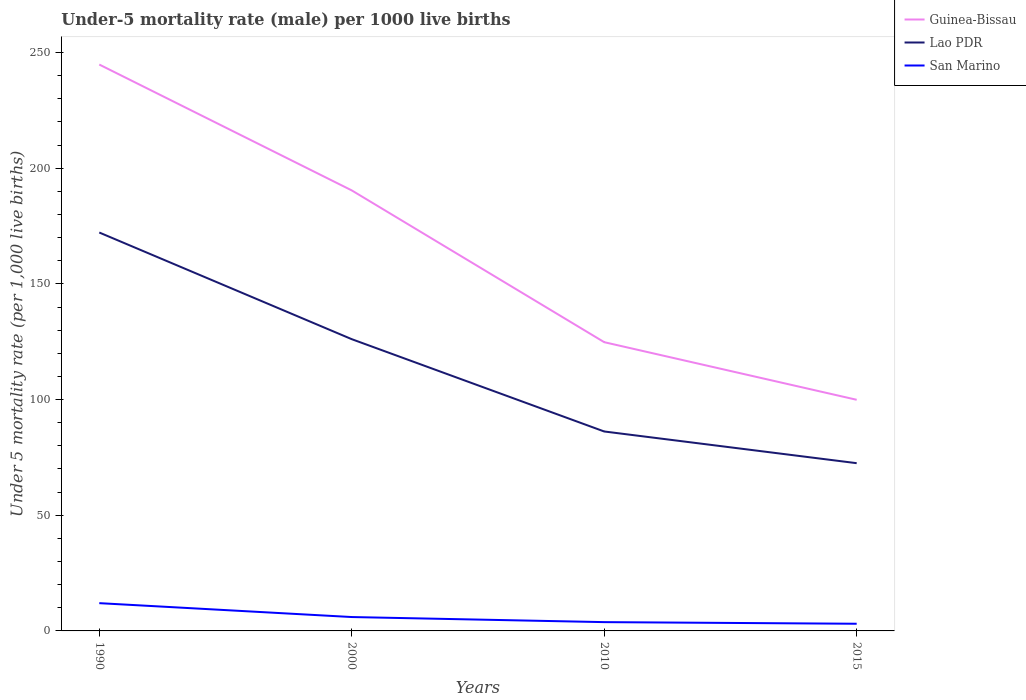How many different coloured lines are there?
Your answer should be very brief. 3. Does the line corresponding to Guinea-Bissau intersect with the line corresponding to San Marino?
Your answer should be very brief. No. Is the number of lines equal to the number of legend labels?
Your answer should be very brief. Yes. In which year was the under-five mortality rate in Guinea-Bissau maximum?
Offer a very short reply. 2015. What is the total under-five mortality rate in Guinea-Bissau in the graph?
Give a very brief answer. 90.5. What is the difference between the highest and the second highest under-five mortality rate in Guinea-Bissau?
Make the answer very short. 144.9. Is the under-five mortality rate in Lao PDR strictly greater than the under-five mortality rate in Guinea-Bissau over the years?
Provide a succinct answer. Yes. What is the difference between two consecutive major ticks on the Y-axis?
Provide a short and direct response. 50. Are the values on the major ticks of Y-axis written in scientific E-notation?
Make the answer very short. No. Does the graph contain grids?
Offer a terse response. No. Where does the legend appear in the graph?
Your answer should be very brief. Top right. How are the legend labels stacked?
Provide a succinct answer. Vertical. What is the title of the graph?
Offer a very short reply. Under-5 mortality rate (male) per 1000 live births. What is the label or title of the Y-axis?
Give a very brief answer. Under 5 mortality rate (per 1,0 live births). What is the Under 5 mortality rate (per 1,000 live births) in Guinea-Bissau in 1990?
Keep it short and to the point. 244.8. What is the Under 5 mortality rate (per 1,000 live births) in Lao PDR in 1990?
Provide a short and direct response. 172.2. What is the Under 5 mortality rate (per 1,000 live births) of San Marino in 1990?
Offer a very short reply. 12. What is the Under 5 mortality rate (per 1,000 live births) of Guinea-Bissau in 2000?
Your answer should be very brief. 190.4. What is the Under 5 mortality rate (per 1,000 live births) of Lao PDR in 2000?
Your response must be concise. 126.1. What is the Under 5 mortality rate (per 1,000 live births) in Guinea-Bissau in 2010?
Offer a terse response. 124.8. What is the Under 5 mortality rate (per 1,000 live births) of Lao PDR in 2010?
Give a very brief answer. 86.2. What is the Under 5 mortality rate (per 1,000 live births) of San Marino in 2010?
Provide a succinct answer. 3.8. What is the Under 5 mortality rate (per 1,000 live births) of Guinea-Bissau in 2015?
Offer a terse response. 99.9. What is the Under 5 mortality rate (per 1,000 live births) of Lao PDR in 2015?
Your answer should be very brief. 72.5. Across all years, what is the maximum Under 5 mortality rate (per 1,000 live births) in Guinea-Bissau?
Ensure brevity in your answer.  244.8. Across all years, what is the maximum Under 5 mortality rate (per 1,000 live births) of Lao PDR?
Offer a very short reply. 172.2. Across all years, what is the maximum Under 5 mortality rate (per 1,000 live births) of San Marino?
Provide a succinct answer. 12. Across all years, what is the minimum Under 5 mortality rate (per 1,000 live births) in Guinea-Bissau?
Offer a very short reply. 99.9. Across all years, what is the minimum Under 5 mortality rate (per 1,000 live births) of Lao PDR?
Your answer should be very brief. 72.5. Across all years, what is the minimum Under 5 mortality rate (per 1,000 live births) of San Marino?
Make the answer very short. 3.1. What is the total Under 5 mortality rate (per 1,000 live births) of Guinea-Bissau in the graph?
Give a very brief answer. 659.9. What is the total Under 5 mortality rate (per 1,000 live births) in Lao PDR in the graph?
Offer a terse response. 457. What is the total Under 5 mortality rate (per 1,000 live births) in San Marino in the graph?
Keep it short and to the point. 24.9. What is the difference between the Under 5 mortality rate (per 1,000 live births) of Guinea-Bissau in 1990 and that in 2000?
Ensure brevity in your answer.  54.4. What is the difference between the Under 5 mortality rate (per 1,000 live births) in Lao PDR in 1990 and that in 2000?
Give a very brief answer. 46.1. What is the difference between the Under 5 mortality rate (per 1,000 live births) of San Marino in 1990 and that in 2000?
Your response must be concise. 6. What is the difference between the Under 5 mortality rate (per 1,000 live births) in Guinea-Bissau in 1990 and that in 2010?
Keep it short and to the point. 120. What is the difference between the Under 5 mortality rate (per 1,000 live births) of San Marino in 1990 and that in 2010?
Offer a very short reply. 8.2. What is the difference between the Under 5 mortality rate (per 1,000 live births) in Guinea-Bissau in 1990 and that in 2015?
Provide a short and direct response. 144.9. What is the difference between the Under 5 mortality rate (per 1,000 live births) in Lao PDR in 1990 and that in 2015?
Keep it short and to the point. 99.7. What is the difference between the Under 5 mortality rate (per 1,000 live births) in San Marino in 1990 and that in 2015?
Ensure brevity in your answer.  8.9. What is the difference between the Under 5 mortality rate (per 1,000 live births) of Guinea-Bissau in 2000 and that in 2010?
Provide a succinct answer. 65.6. What is the difference between the Under 5 mortality rate (per 1,000 live births) in Lao PDR in 2000 and that in 2010?
Offer a terse response. 39.9. What is the difference between the Under 5 mortality rate (per 1,000 live births) of San Marino in 2000 and that in 2010?
Your answer should be very brief. 2.2. What is the difference between the Under 5 mortality rate (per 1,000 live births) in Guinea-Bissau in 2000 and that in 2015?
Ensure brevity in your answer.  90.5. What is the difference between the Under 5 mortality rate (per 1,000 live births) of Lao PDR in 2000 and that in 2015?
Offer a terse response. 53.6. What is the difference between the Under 5 mortality rate (per 1,000 live births) of Guinea-Bissau in 2010 and that in 2015?
Your response must be concise. 24.9. What is the difference between the Under 5 mortality rate (per 1,000 live births) in San Marino in 2010 and that in 2015?
Keep it short and to the point. 0.7. What is the difference between the Under 5 mortality rate (per 1,000 live births) of Guinea-Bissau in 1990 and the Under 5 mortality rate (per 1,000 live births) of Lao PDR in 2000?
Your response must be concise. 118.7. What is the difference between the Under 5 mortality rate (per 1,000 live births) of Guinea-Bissau in 1990 and the Under 5 mortality rate (per 1,000 live births) of San Marino in 2000?
Give a very brief answer. 238.8. What is the difference between the Under 5 mortality rate (per 1,000 live births) of Lao PDR in 1990 and the Under 5 mortality rate (per 1,000 live births) of San Marino in 2000?
Give a very brief answer. 166.2. What is the difference between the Under 5 mortality rate (per 1,000 live births) of Guinea-Bissau in 1990 and the Under 5 mortality rate (per 1,000 live births) of Lao PDR in 2010?
Your answer should be very brief. 158.6. What is the difference between the Under 5 mortality rate (per 1,000 live births) of Guinea-Bissau in 1990 and the Under 5 mortality rate (per 1,000 live births) of San Marino in 2010?
Provide a short and direct response. 241. What is the difference between the Under 5 mortality rate (per 1,000 live births) in Lao PDR in 1990 and the Under 5 mortality rate (per 1,000 live births) in San Marino in 2010?
Make the answer very short. 168.4. What is the difference between the Under 5 mortality rate (per 1,000 live births) of Guinea-Bissau in 1990 and the Under 5 mortality rate (per 1,000 live births) of Lao PDR in 2015?
Your answer should be compact. 172.3. What is the difference between the Under 5 mortality rate (per 1,000 live births) of Guinea-Bissau in 1990 and the Under 5 mortality rate (per 1,000 live births) of San Marino in 2015?
Ensure brevity in your answer.  241.7. What is the difference between the Under 5 mortality rate (per 1,000 live births) of Lao PDR in 1990 and the Under 5 mortality rate (per 1,000 live births) of San Marino in 2015?
Provide a short and direct response. 169.1. What is the difference between the Under 5 mortality rate (per 1,000 live births) in Guinea-Bissau in 2000 and the Under 5 mortality rate (per 1,000 live births) in Lao PDR in 2010?
Make the answer very short. 104.2. What is the difference between the Under 5 mortality rate (per 1,000 live births) of Guinea-Bissau in 2000 and the Under 5 mortality rate (per 1,000 live births) of San Marino in 2010?
Your answer should be very brief. 186.6. What is the difference between the Under 5 mortality rate (per 1,000 live births) of Lao PDR in 2000 and the Under 5 mortality rate (per 1,000 live births) of San Marino in 2010?
Your answer should be compact. 122.3. What is the difference between the Under 5 mortality rate (per 1,000 live births) of Guinea-Bissau in 2000 and the Under 5 mortality rate (per 1,000 live births) of Lao PDR in 2015?
Your answer should be very brief. 117.9. What is the difference between the Under 5 mortality rate (per 1,000 live births) in Guinea-Bissau in 2000 and the Under 5 mortality rate (per 1,000 live births) in San Marino in 2015?
Keep it short and to the point. 187.3. What is the difference between the Under 5 mortality rate (per 1,000 live births) in Lao PDR in 2000 and the Under 5 mortality rate (per 1,000 live births) in San Marino in 2015?
Your answer should be compact. 123. What is the difference between the Under 5 mortality rate (per 1,000 live births) of Guinea-Bissau in 2010 and the Under 5 mortality rate (per 1,000 live births) of Lao PDR in 2015?
Your response must be concise. 52.3. What is the difference between the Under 5 mortality rate (per 1,000 live births) of Guinea-Bissau in 2010 and the Under 5 mortality rate (per 1,000 live births) of San Marino in 2015?
Offer a terse response. 121.7. What is the difference between the Under 5 mortality rate (per 1,000 live births) of Lao PDR in 2010 and the Under 5 mortality rate (per 1,000 live births) of San Marino in 2015?
Provide a succinct answer. 83.1. What is the average Under 5 mortality rate (per 1,000 live births) in Guinea-Bissau per year?
Offer a terse response. 164.97. What is the average Under 5 mortality rate (per 1,000 live births) of Lao PDR per year?
Provide a short and direct response. 114.25. What is the average Under 5 mortality rate (per 1,000 live births) of San Marino per year?
Your answer should be very brief. 6.22. In the year 1990, what is the difference between the Under 5 mortality rate (per 1,000 live births) of Guinea-Bissau and Under 5 mortality rate (per 1,000 live births) of Lao PDR?
Your answer should be very brief. 72.6. In the year 1990, what is the difference between the Under 5 mortality rate (per 1,000 live births) of Guinea-Bissau and Under 5 mortality rate (per 1,000 live births) of San Marino?
Make the answer very short. 232.8. In the year 1990, what is the difference between the Under 5 mortality rate (per 1,000 live births) in Lao PDR and Under 5 mortality rate (per 1,000 live births) in San Marino?
Provide a succinct answer. 160.2. In the year 2000, what is the difference between the Under 5 mortality rate (per 1,000 live births) of Guinea-Bissau and Under 5 mortality rate (per 1,000 live births) of Lao PDR?
Provide a short and direct response. 64.3. In the year 2000, what is the difference between the Under 5 mortality rate (per 1,000 live births) in Guinea-Bissau and Under 5 mortality rate (per 1,000 live births) in San Marino?
Your response must be concise. 184.4. In the year 2000, what is the difference between the Under 5 mortality rate (per 1,000 live births) in Lao PDR and Under 5 mortality rate (per 1,000 live births) in San Marino?
Provide a short and direct response. 120.1. In the year 2010, what is the difference between the Under 5 mortality rate (per 1,000 live births) of Guinea-Bissau and Under 5 mortality rate (per 1,000 live births) of Lao PDR?
Your answer should be very brief. 38.6. In the year 2010, what is the difference between the Under 5 mortality rate (per 1,000 live births) in Guinea-Bissau and Under 5 mortality rate (per 1,000 live births) in San Marino?
Provide a short and direct response. 121. In the year 2010, what is the difference between the Under 5 mortality rate (per 1,000 live births) in Lao PDR and Under 5 mortality rate (per 1,000 live births) in San Marino?
Keep it short and to the point. 82.4. In the year 2015, what is the difference between the Under 5 mortality rate (per 1,000 live births) of Guinea-Bissau and Under 5 mortality rate (per 1,000 live births) of Lao PDR?
Your answer should be compact. 27.4. In the year 2015, what is the difference between the Under 5 mortality rate (per 1,000 live births) of Guinea-Bissau and Under 5 mortality rate (per 1,000 live births) of San Marino?
Offer a terse response. 96.8. In the year 2015, what is the difference between the Under 5 mortality rate (per 1,000 live births) in Lao PDR and Under 5 mortality rate (per 1,000 live births) in San Marino?
Ensure brevity in your answer.  69.4. What is the ratio of the Under 5 mortality rate (per 1,000 live births) in Lao PDR in 1990 to that in 2000?
Offer a terse response. 1.37. What is the ratio of the Under 5 mortality rate (per 1,000 live births) in San Marino in 1990 to that in 2000?
Your response must be concise. 2. What is the ratio of the Under 5 mortality rate (per 1,000 live births) of Guinea-Bissau in 1990 to that in 2010?
Give a very brief answer. 1.96. What is the ratio of the Under 5 mortality rate (per 1,000 live births) in Lao PDR in 1990 to that in 2010?
Give a very brief answer. 2. What is the ratio of the Under 5 mortality rate (per 1,000 live births) in San Marino in 1990 to that in 2010?
Offer a terse response. 3.16. What is the ratio of the Under 5 mortality rate (per 1,000 live births) in Guinea-Bissau in 1990 to that in 2015?
Provide a succinct answer. 2.45. What is the ratio of the Under 5 mortality rate (per 1,000 live births) in Lao PDR in 1990 to that in 2015?
Your response must be concise. 2.38. What is the ratio of the Under 5 mortality rate (per 1,000 live births) of San Marino in 1990 to that in 2015?
Make the answer very short. 3.87. What is the ratio of the Under 5 mortality rate (per 1,000 live births) of Guinea-Bissau in 2000 to that in 2010?
Your answer should be very brief. 1.53. What is the ratio of the Under 5 mortality rate (per 1,000 live births) of Lao PDR in 2000 to that in 2010?
Your response must be concise. 1.46. What is the ratio of the Under 5 mortality rate (per 1,000 live births) of San Marino in 2000 to that in 2010?
Your answer should be compact. 1.58. What is the ratio of the Under 5 mortality rate (per 1,000 live births) in Guinea-Bissau in 2000 to that in 2015?
Provide a short and direct response. 1.91. What is the ratio of the Under 5 mortality rate (per 1,000 live births) in Lao PDR in 2000 to that in 2015?
Your answer should be very brief. 1.74. What is the ratio of the Under 5 mortality rate (per 1,000 live births) in San Marino in 2000 to that in 2015?
Your answer should be very brief. 1.94. What is the ratio of the Under 5 mortality rate (per 1,000 live births) of Guinea-Bissau in 2010 to that in 2015?
Provide a succinct answer. 1.25. What is the ratio of the Under 5 mortality rate (per 1,000 live births) in Lao PDR in 2010 to that in 2015?
Make the answer very short. 1.19. What is the ratio of the Under 5 mortality rate (per 1,000 live births) in San Marino in 2010 to that in 2015?
Make the answer very short. 1.23. What is the difference between the highest and the second highest Under 5 mortality rate (per 1,000 live births) in Guinea-Bissau?
Your answer should be compact. 54.4. What is the difference between the highest and the second highest Under 5 mortality rate (per 1,000 live births) of Lao PDR?
Your answer should be compact. 46.1. What is the difference between the highest and the lowest Under 5 mortality rate (per 1,000 live births) in Guinea-Bissau?
Provide a short and direct response. 144.9. What is the difference between the highest and the lowest Under 5 mortality rate (per 1,000 live births) of Lao PDR?
Your response must be concise. 99.7. What is the difference between the highest and the lowest Under 5 mortality rate (per 1,000 live births) of San Marino?
Provide a succinct answer. 8.9. 